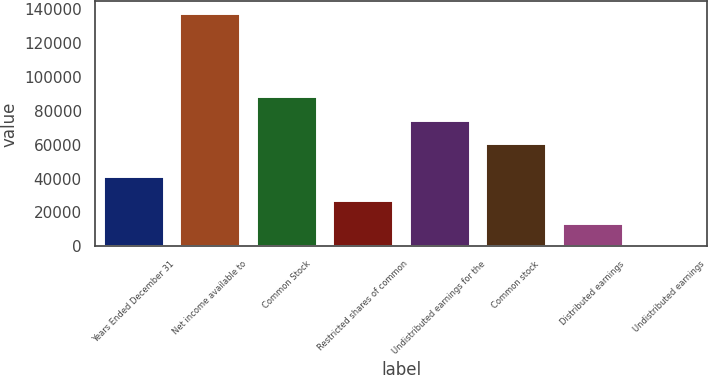Convert chart. <chart><loc_0><loc_0><loc_500><loc_500><bar_chart><fcel>Years Ended December 31<fcel>Net income available to<fcel>Common Stock<fcel>Restricted shares of common<fcel>Undistributed earnings for the<fcel>Common stock<fcel>Distributed earnings<fcel>Undistributed earnings<nl><fcel>41299.4<fcel>137664<fcel>88533.7<fcel>27533<fcel>74767.4<fcel>61001<fcel>13766.6<fcel>0.28<nl></chart> 